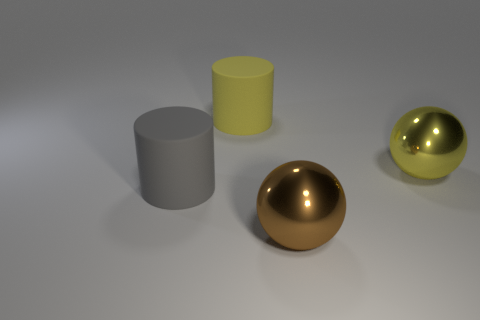There is a big cylinder that is on the left side of the big yellow thing that is left of the large ball in front of the gray cylinder; what is its material?
Your response must be concise. Rubber. There is a big shiny sphere on the left side of the yellow shiny sphere; is it the same color as the shiny ball behind the large brown object?
Your answer should be compact. No. What is the material of the big gray cylinder that is on the left side of the big cylinder behind the gray cylinder?
Provide a succinct answer. Rubber. What is the color of the metallic thing that is the same size as the yellow shiny sphere?
Your response must be concise. Brown. Is the shape of the brown object the same as the object that is on the right side of the big brown metallic ball?
Offer a terse response. Yes. There is a large yellow thing to the left of the metal sphere that is in front of the big yellow metal object; what number of shiny balls are left of it?
Provide a short and direct response. 0. What size is the yellow object that is right of the big thing that is behind the yellow shiny sphere?
Your answer should be very brief. Large. The gray thing that is made of the same material as the big yellow cylinder is what size?
Provide a short and direct response. Large. What is the shape of the object that is both on the left side of the brown metallic thing and behind the large gray rubber cylinder?
Provide a short and direct response. Cylinder. Are there the same number of cylinders that are left of the yellow shiny object and brown shiny balls?
Give a very brief answer. No. 